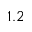<formula> <loc_0><loc_0><loc_500><loc_500>1 . 2</formula> 